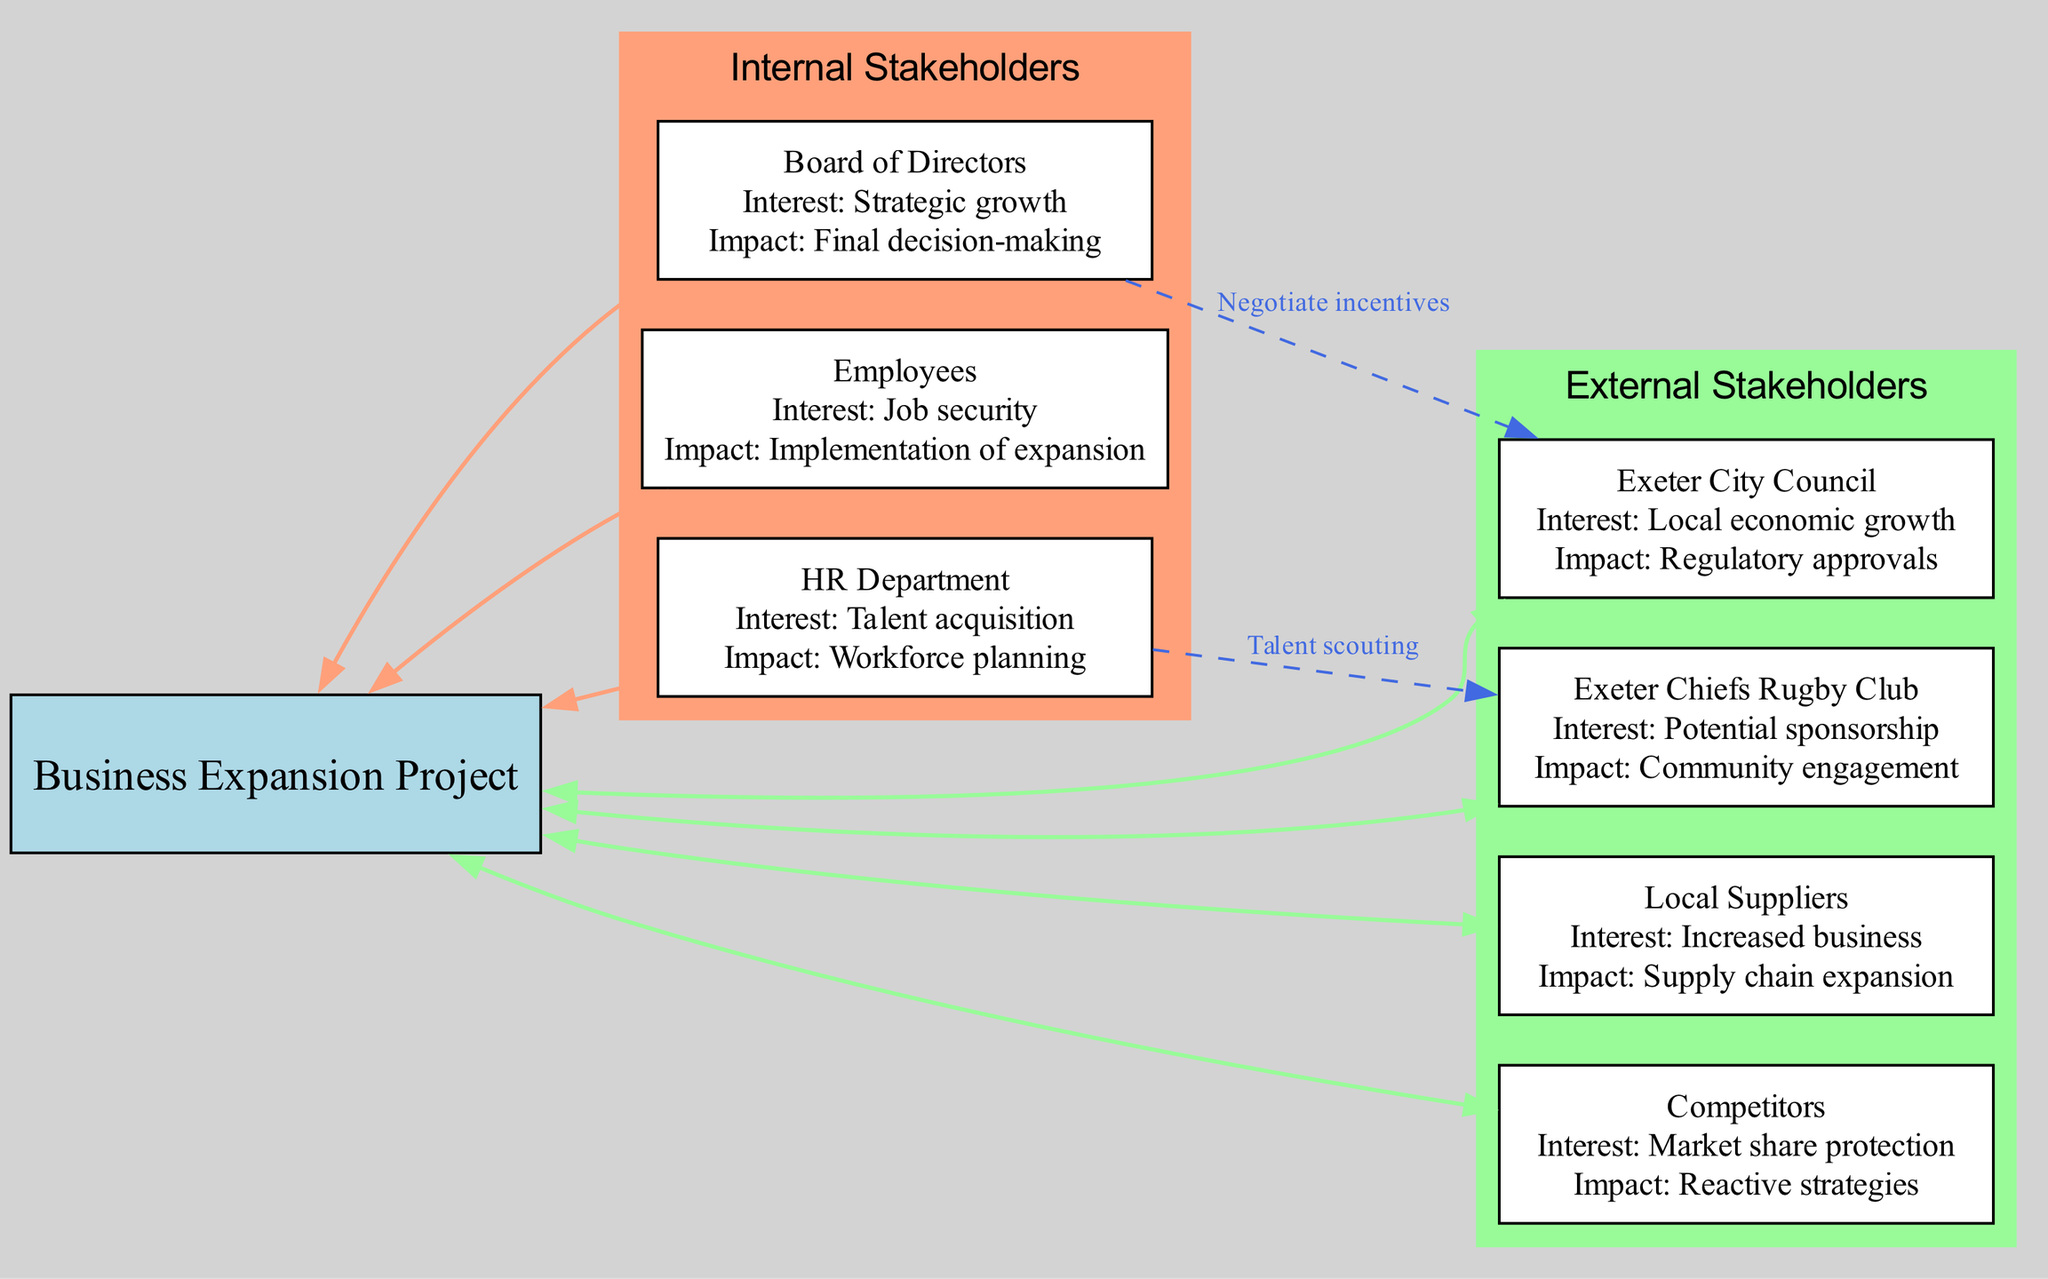What is the central node of the diagram? The central node represents the main focus of the stakeholder analysis, which is the "Business Expansion Project." This information can be found at the center of the diagram.
Answer: Business Expansion Project How many internal stakeholders are there? The diagram lists three internal stakeholders: Board of Directors, Employees, and HR Department. Count the nodes labeled as internal to find this number.
Answer: 3 What is the interest of the HR Department? The HR Department's interest is stated in the diagram as "Talent acquisition." This information is provided directly next to their node.
Answer: Talent acquisition What connection exists between the Board of Directors and Exeter City Council? The connection labeled as "Negotiate incentives" clearly indicates the relationship between these two stakeholders. This is discernible from the edge drawn from the Board of Directors to Exeter City Council.
Answer: Negotiate incentives Which external stakeholder is associated with community engagement? The Exeter Chiefs Rugby Club is associated with community engagement, as stated in their node under the external stakeholders category.
Answer: Exeter Chiefs Rugby Club What interest does the Exeter City Council have? The Exeter City Council's interest is defined as "Local economic growth," which is specifically noted in the diagram next to their node.
Answer: Local economic growth How many connections are depicted in the diagram? There are two connections illustrated in the diagram: one from the Board of Directors to Exeter City Council and another from the HR Department to Exeter Chiefs Rugby Club. Count these edges to determine the total.
Answer: 2 What potential impact do competitors have on the business expansion? The competitors' potential impact is described as "Reactive strategies," which indicates how they may respond to the expansion project, as noted next to their stakeholder node.
Answer: Reactive strategies What is the interest of local suppliers? The local suppliers' interest is documented as "Increased business," which is stated directly next to their node in the diagram.
Answer: Increased business 